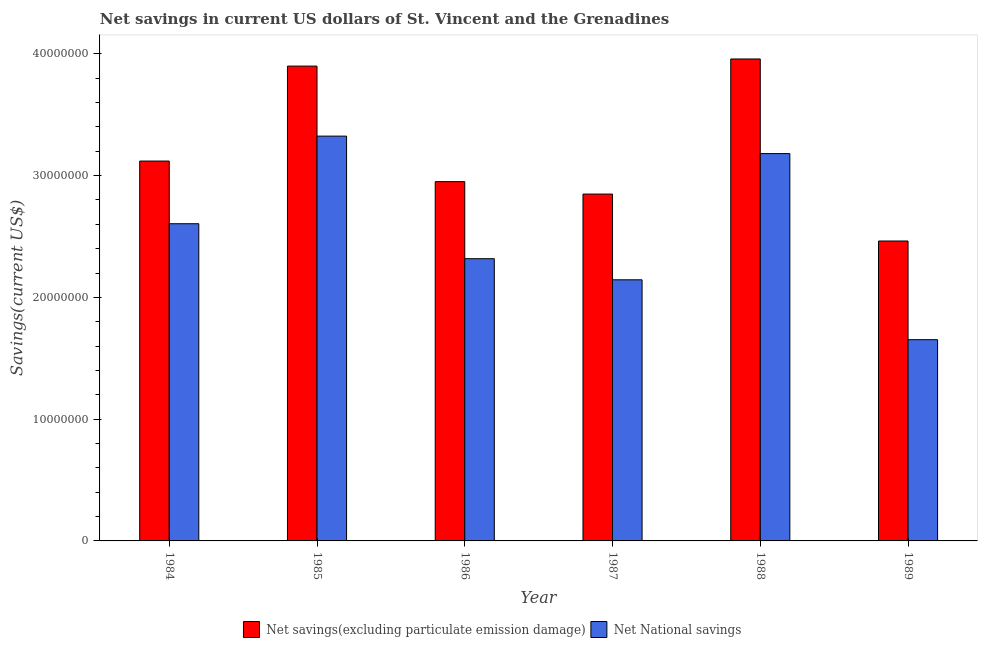How many different coloured bars are there?
Give a very brief answer. 2. Are the number of bars on each tick of the X-axis equal?
Give a very brief answer. Yes. How many bars are there on the 3rd tick from the left?
Your response must be concise. 2. How many bars are there on the 6th tick from the right?
Keep it short and to the point. 2. What is the net national savings in 1985?
Offer a very short reply. 3.32e+07. Across all years, what is the maximum net national savings?
Give a very brief answer. 3.32e+07. Across all years, what is the minimum net savings(excluding particulate emission damage)?
Provide a succinct answer. 2.46e+07. In which year was the net savings(excluding particulate emission damage) minimum?
Keep it short and to the point. 1989. What is the total net national savings in the graph?
Offer a very short reply. 1.52e+08. What is the difference between the net national savings in 1988 and that in 1989?
Give a very brief answer. 1.53e+07. What is the difference between the net national savings in 1988 and the net savings(excluding particulate emission damage) in 1986?
Make the answer very short. 8.63e+06. What is the average net national savings per year?
Your answer should be very brief. 2.54e+07. In how many years, is the net savings(excluding particulate emission damage) greater than 32000000 US$?
Your response must be concise. 2. What is the ratio of the net savings(excluding particulate emission damage) in 1984 to that in 1985?
Your response must be concise. 0.8. Is the difference between the net savings(excluding particulate emission damage) in 1985 and 1987 greater than the difference between the net national savings in 1985 and 1987?
Your answer should be very brief. No. What is the difference between the highest and the second highest net national savings?
Offer a very short reply. 1.44e+06. What is the difference between the highest and the lowest net national savings?
Your answer should be very brief. 1.67e+07. In how many years, is the net savings(excluding particulate emission damage) greater than the average net savings(excluding particulate emission damage) taken over all years?
Give a very brief answer. 2. What does the 2nd bar from the left in 1985 represents?
Your response must be concise. Net National savings. What does the 2nd bar from the right in 1986 represents?
Offer a terse response. Net savings(excluding particulate emission damage). How many bars are there?
Provide a succinct answer. 12. Are all the bars in the graph horizontal?
Your answer should be compact. No. What is the difference between two consecutive major ticks on the Y-axis?
Your answer should be very brief. 1.00e+07. Does the graph contain any zero values?
Your response must be concise. No. Does the graph contain grids?
Provide a succinct answer. No. Where does the legend appear in the graph?
Your answer should be compact. Bottom center. How many legend labels are there?
Your response must be concise. 2. How are the legend labels stacked?
Your answer should be compact. Horizontal. What is the title of the graph?
Keep it short and to the point. Net savings in current US dollars of St. Vincent and the Grenadines. What is the label or title of the X-axis?
Your answer should be very brief. Year. What is the label or title of the Y-axis?
Provide a succinct answer. Savings(current US$). What is the Savings(current US$) of Net savings(excluding particulate emission damage) in 1984?
Your answer should be very brief. 3.12e+07. What is the Savings(current US$) of Net National savings in 1984?
Make the answer very short. 2.60e+07. What is the Savings(current US$) in Net savings(excluding particulate emission damage) in 1985?
Your answer should be very brief. 3.90e+07. What is the Savings(current US$) in Net National savings in 1985?
Your answer should be very brief. 3.32e+07. What is the Savings(current US$) in Net savings(excluding particulate emission damage) in 1986?
Ensure brevity in your answer.  2.95e+07. What is the Savings(current US$) in Net National savings in 1986?
Keep it short and to the point. 2.32e+07. What is the Savings(current US$) in Net savings(excluding particulate emission damage) in 1987?
Your response must be concise. 2.85e+07. What is the Savings(current US$) of Net National savings in 1987?
Provide a succinct answer. 2.14e+07. What is the Savings(current US$) of Net savings(excluding particulate emission damage) in 1988?
Give a very brief answer. 3.96e+07. What is the Savings(current US$) of Net National savings in 1988?
Your answer should be very brief. 3.18e+07. What is the Savings(current US$) in Net savings(excluding particulate emission damage) in 1989?
Your response must be concise. 2.46e+07. What is the Savings(current US$) in Net National savings in 1989?
Ensure brevity in your answer.  1.65e+07. Across all years, what is the maximum Savings(current US$) in Net savings(excluding particulate emission damage)?
Offer a terse response. 3.96e+07. Across all years, what is the maximum Savings(current US$) in Net National savings?
Your answer should be compact. 3.32e+07. Across all years, what is the minimum Savings(current US$) of Net savings(excluding particulate emission damage)?
Make the answer very short. 2.46e+07. Across all years, what is the minimum Savings(current US$) of Net National savings?
Your answer should be very brief. 1.65e+07. What is the total Savings(current US$) of Net savings(excluding particulate emission damage) in the graph?
Offer a terse response. 1.92e+08. What is the total Savings(current US$) of Net National savings in the graph?
Ensure brevity in your answer.  1.52e+08. What is the difference between the Savings(current US$) in Net savings(excluding particulate emission damage) in 1984 and that in 1985?
Your answer should be very brief. -7.80e+06. What is the difference between the Savings(current US$) in Net National savings in 1984 and that in 1985?
Ensure brevity in your answer.  -7.19e+06. What is the difference between the Savings(current US$) of Net savings(excluding particulate emission damage) in 1984 and that in 1986?
Provide a succinct answer. 1.69e+06. What is the difference between the Savings(current US$) of Net National savings in 1984 and that in 1986?
Offer a very short reply. 2.87e+06. What is the difference between the Savings(current US$) in Net savings(excluding particulate emission damage) in 1984 and that in 1987?
Ensure brevity in your answer.  2.71e+06. What is the difference between the Savings(current US$) of Net National savings in 1984 and that in 1987?
Make the answer very short. 4.61e+06. What is the difference between the Savings(current US$) of Net savings(excluding particulate emission damage) in 1984 and that in 1988?
Your answer should be very brief. -8.38e+06. What is the difference between the Savings(current US$) of Net National savings in 1984 and that in 1988?
Provide a short and direct response. -5.76e+06. What is the difference between the Savings(current US$) of Net savings(excluding particulate emission damage) in 1984 and that in 1989?
Give a very brief answer. 6.57e+06. What is the difference between the Savings(current US$) of Net National savings in 1984 and that in 1989?
Give a very brief answer. 9.52e+06. What is the difference between the Savings(current US$) of Net savings(excluding particulate emission damage) in 1985 and that in 1986?
Offer a terse response. 9.49e+06. What is the difference between the Savings(current US$) in Net National savings in 1985 and that in 1986?
Offer a terse response. 1.01e+07. What is the difference between the Savings(current US$) of Net savings(excluding particulate emission damage) in 1985 and that in 1987?
Provide a succinct answer. 1.05e+07. What is the difference between the Savings(current US$) in Net National savings in 1985 and that in 1987?
Make the answer very short. 1.18e+07. What is the difference between the Savings(current US$) in Net savings(excluding particulate emission damage) in 1985 and that in 1988?
Provide a short and direct response. -5.86e+05. What is the difference between the Savings(current US$) of Net National savings in 1985 and that in 1988?
Offer a very short reply. 1.44e+06. What is the difference between the Savings(current US$) of Net savings(excluding particulate emission damage) in 1985 and that in 1989?
Keep it short and to the point. 1.44e+07. What is the difference between the Savings(current US$) in Net National savings in 1985 and that in 1989?
Provide a succinct answer. 1.67e+07. What is the difference between the Savings(current US$) of Net savings(excluding particulate emission damage) in 1986 and that in 1987?
Your response must be concise. 1.02e+06. What is the difference between the Savings(current US$) in Net National savings in 1986 and that in 1987?
Your answer should be very brief. 1.73e+06. What is the difference between the Savings(current US$) of Net savings(excluding particulate emission damage) in 1986 and that in 1988?
Keep it short and to the point. -1.01e+07. What is the difference between the Savings(current US$) of Net National savings in 1986 and that in 1988?
Your response must be concise. -8.63e+06. What is the difference between the Savings(current US$) in Net savings(excluding particulate emission damage) in 1986 and that in 1989?
Your response must be concise. 4.88e+06. What is the difference between the Savings(current US$) of Net National savings in 1986 and that in 1989?
Provide a short and direct response. 6.65e+06. What is the difference between the Savings(current US$) in Net savings(excluding particulate emission damage) in 1987 and that in 1988?
Offer a terse response. -1.11e+07. What is the difference between the Savings(current US$) in Net National savings in 1987 and that in 1988?
Your answer should be compact. -1.04e+07. What is the difference between the Savings(current US$) in Net savings(excluding particulate emission damage) in 1987 and that in 1989?
Give a very brief answer. 3.85e+06. What is the difference between the Savings(current US$) of Net National savings in 1987 and that in 1989?
Provide a short and direct response. 4.92e+06. What is the difference between the Savings(current US$) of Net savings(excluding particulate emission damage) in 1988 and that in 1989?
Ensure brevity in your answer.  1.49e+07. What is the difference between the Savings(current US$) of Net National savings in 1988 and that in 1989?
Offer a very short reply. 1.53e+07. What is the difference between the Savings(current US$) of Net savings(excluding particulate emission damage) in 1984 and the Savings(current US$) of Net National savings in 1985?
Offer a very short reply. -2.05e+06. What is the difference between the Savings(current US$) in Net savings(excluding particulate emission damage) in 1984 and the Savings(current US$) in Net National savings in 1986?
Give a very brief answer. 8.02e+06. What is the difference between the Savings(current US$) of Net savings(excluding particulate emission damage) in 1984 and the Savings(current US$) of Net National savings in 1987?
Keep it short and to the point. 9.75e+06. What is the difference between the Savings(current US$) in Net savings(excluding particulate emission damage) in 1984 and the Savings(current US$) in Net National savings in 1988?
Ensure brevity in your answer.  -6.12e+05. What is the difference between the Savings(current US$) of Net savings(excluding particulate emission damage) in 1984 and the Savings(current US$) of Net National savings in 1989?
Your answer should be compact. 1.47e+07. What is the difference between the Savings(current US$) of Net savings(excluding particulate emission damage) in 1985 and the Savings(current US$) of Net National savings in 1986?
Ensure brevity in your answer.  1.58e+07. What is the difference between the Savings(current US$) in Net savings(excluding particulate emission damage) in 1985 and the Savings(current US$) in Net National savings in 1987?
Provide a short and direct response. 1.76e+07. What is the difference between the Savings(current US$) of Net savings(excluding particulate emission damage) in 1985 and the Savings(current US$) of Net National savings in 1988?
Give a very brief answer. 7.18e+06. What is the difference between the Savings(current US$) in Net savings(excluding particulate emission damage) in 1985 and the Savings(current US$) in Net National savings in 1989?
Keep it short and to the point. 2.25e+07. What is the difference between the Savings(current US$) in Net savings(excluding particulate emission damage) in 1986 and the Savings(current US$) in Net National savings in 1987?
Your answer should be very brief. 8.06e+06. What is the difference between the Savings(current US$) of Net savings(excluding particulate emission damage) in 1986 and the Savings(current US$) of Net National savings in 1988?
Your answer should be compact. -2.30e+06. What is the difference between the Savings(current US$) of Net savings(excluding particulate emission damage) in 1986 and the Savings(current US$) of Net National savings in 1989?
Your answer should be very brief. 1.30e+07. What is the difference between the Savings(current US$) in Net savings(excluding particulate emission damage) in 1987 and the Savings(current US$) in Net National savings in 1988?
Make the answer very short. -3.32e+06. What is the difference between the Savings(current US$) in Net savings(excluding particulate emission damage) in 1987 and the Savings(current US$) in Net National savings in 1989?
Your answer should be very brief. 1.20e+07. What is the difference between the Savings(current US$) in Net savings(excluding particulate emission damage) in 1988 and the Savings(current US$) in Net National savings in 1989?
Offer a very short reply. 2.31e+07. What is the average Savings(current US$) in Net savings(excluding particulate emission damage) per year?
Provide a succinct answer. 3.21e+07. What is the average Savings(current US$) of Net National savings per year?
Keep it short and to the point. 2.54e+07. In the year 1984, what is the difference between the Savings(current US$) of Net savings(excluding particulate emission damage) and Savings(current US$) of Net National savings?
Give a very brief answer. 5.15e+06. In the year 1985, what is the difference between the Savings(current US$) of Net savings(excluding particulate emission damage) and Savings(current US$) of Net National savings?
Make the answer very short. 5.75e+06. In the year 1986, what is the difference between the Savings(current US$) in Net savings(excluding particulate emission damage) and Savings(current US$) in Net National savings?
Your answer should be compact. 6.33e+06. In the year 1987, what is the difference between the Savings(current US$) of Net savings(excluding particulate emission damage) and Savings(current US$) of Net National savings?
Your response must be concise. 7.04e+06. In the year 1988, what is the difference between the Savings(current US$) in Net savings(excluding particulate emission damage) and Savings(current US$) in Net National savings?
Give a very brief answer. 7.77e+06. In the year 1989, what is the difference between the Savings(current US$) in Net savings(excluding particulate emission damage) and Savings(current US$) in Net National savings?
Keep it short and to the point. 8.10e+06. What is the ratio of the Savings(current US$) in Net National savings in 1984 to that in 1985?
Keep it short and to the point. 0.78. What is the ratio of the Savings(current US$) of Net savings(excluding particulate emission damage) in 1984 to that in 1986?
Keep it short and to the point. 1.06. What is the ratio of the Savings(current US$) in Net National savings in 1984 to that in 1986?
Make the answer very short. 1.12. What is the ratio of the Savings(current US$) of Net savings(excluding particulate emission damage) in 1984 to that in 1987?
Your answer should be compact. 1.1. What is the ratio of the Savings(current US$) in Net National savings in 1984 to that in 1987?
Give a very brief answer. 1.21. What is the ratio of the Savings(current US$) in Net savings(excluding particulate emission damage) in 1984 to that in 1988?
Your answer should be very brief. 0.79. What is the ratio of the Savings(current US$) in Net National savings in 1984 to that in 1988?
Offer a very short reply. 0.82. What is the ratio of the Savings(current US$) in Net savings(excluding particulate emission damage) in 1984 to that in 1989?
Make the answer very short. 1.27. What is the ratio of the Savings(current US$) in Net National savings in 1984 to that in 1989?
Ensure brevity in your answer.  1.58. What is the ratio of the Savings(current US$) of Net savings(excluding particulate emission damage) in 1985 to that in 1986?
Keep it short and to the point. 1.32. What is the ratio of the Savings(current US$) in Net National savings in 1985 to that in 1986?
Provide a succinct answer. 1.43. What is the ratio of the Savings(current US$) in Net savings(excluding particulate emission damage) in 1985 to that in 1987?
Give a very brief answer. 1.37. What is the ratio of the Savings(current US$) in Net National savings in 1985 to that in 1987?
Make the answer very short. 1.55. What is the ratio of the Savings(current US$) in Net savings(excluding particulate emission damage) in 1985 to that in 1988?
Your response must be concise. 0.99. What is the ratio of the Savings(current US$) of Net National savings in 1985 to that in 1988?
Your answer should be very brief. 1.05. What is the ratio of the Savings(current US$) of Net savings(excluding particulate emission damage) in 1985 to that in 1989?
Your answer should be very brief. 1.58. What is the ratio of the Savings(current US$) in Net National savings in 1985 to that in 1989?
Make the answer very short. 2.01. What is the ratio of the Savings(current US$) in Net savings(excluding particulate emission damage) in 1986 to that in 1987?
Offer a very short reply. 1.04. What is the ratio of the Savings(current US$) of Net National savings in 1986 to that in 1987?
Offer a very short reply. 1.08. What is the ratio of the Savings(current US$) in Net savings(excluding particulate emission damage) in 1986 to that in 1988?
Offer a very short reply. 0.75. What is the ratio of the Savings(current US$) of Net National savings in 1986 to that in 1988?
Your answer should be compact. 0.73. What is the ratio of the Savings(current US$) in Net savings(excluding particulate emission damage) in 1986 to that in 1989?
Provide a short and direct response. 1.2. What is the ratio of the Savings(current US$) in Net National savings in 1986 to that in 1989?
Offer a terse response. 1.4. What is the ratio of the Savings(current US$) in Net savings(excluding particulate emission damage) in 1987 to that in 1988?
Make the answer very short. 0.72. What is the ratio of the Savings(current US$) in Net National savings in 1987 to that in 1988?
Provide a short and direct response. 0.67. What is the ratio of the Savings(current US$) in Net savings(excluding particulate emission damage) in 1987 to that in 1989?
Your answer should be compact. 1.16. What is the ratio of the Savings(current US$) of Net National savings in 1987 to that in 1989?
Give a very brief answer. 1.3. What is the ratio of the Savings(current US$) in Net savings(excluding particulate emission damage) in 1988 to that in 1989?
Provide a succinct answer. 1.61. What is the ratio of the Savings(current US$) of Net National savings in 1988 to that in 1989?
Make the answer very short. 1.92. What is the difference between the highest and the second highest Savings(current US$) of Net savings(excluding particulate emission damage)?
Make the answer very short. 5.86e+05. What is the difference between the highest and the second highest Savings(current US$) of Net National savings?
Ensure brevity in your answer.  1.44e+06. What is the difference between the highest and the lowest Savings(current US$) of Net savings(excluding particulate emission damage)?
Your answer should be compact. 1.49e+07. What is the difference between the highest and the lowest Savings(current US$) in Net National savings?
Your response must be concise. 1.67e+07. 